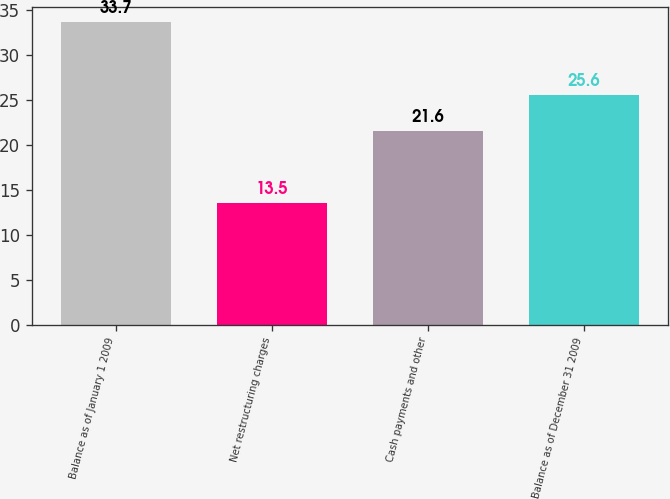Convert chart. <chart><loc_0><loc_0><loc_500><loc_500><bar_chart><fcel>Balance as of January 1 2009<fcel>Net restructuring charges<fcel>Cash payments and other<fcel>Balance as of December 31 2009<nl><fcel>33.7<fcel>13.5<fcel>21.6<fcel>25.6<nl></chart> 